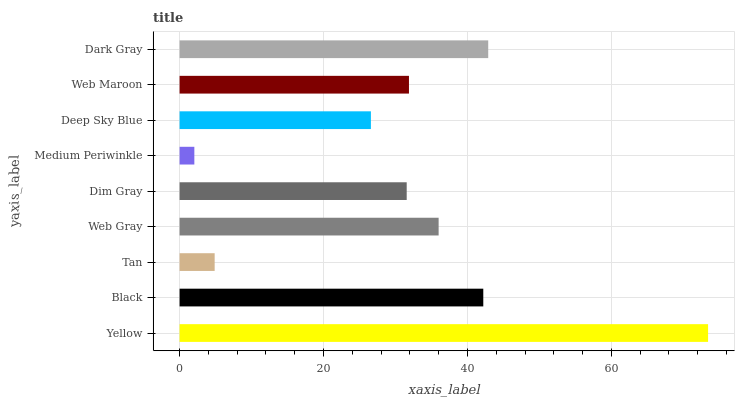Is Medium Periwinkle the minimum?
Answer yes or no. Yes. Is Yellow the maximum?
Answer yes or no. Yes. Is Black the minimum?
Answer yes or no. No. Is Black the maximum?
Answer yes or no. No. Is Yellow greater than Black?
Answer yes or no. Yes. Is Black less than Yellow?
Answer yes or no. Yes. Is Black greater than Yellow?
Answer yes or no. No. Is Yellow less than Black?
Answer yes or no. No. Is Web Maroon the high median?
Answer yes or no. Yes. Is Web Maroon the low median?
Answer yes or no. Yes. Is Dim Gray the high median?
Answer yes or no. No. Is Web Gray the low median?
Answer yes or no. No. 